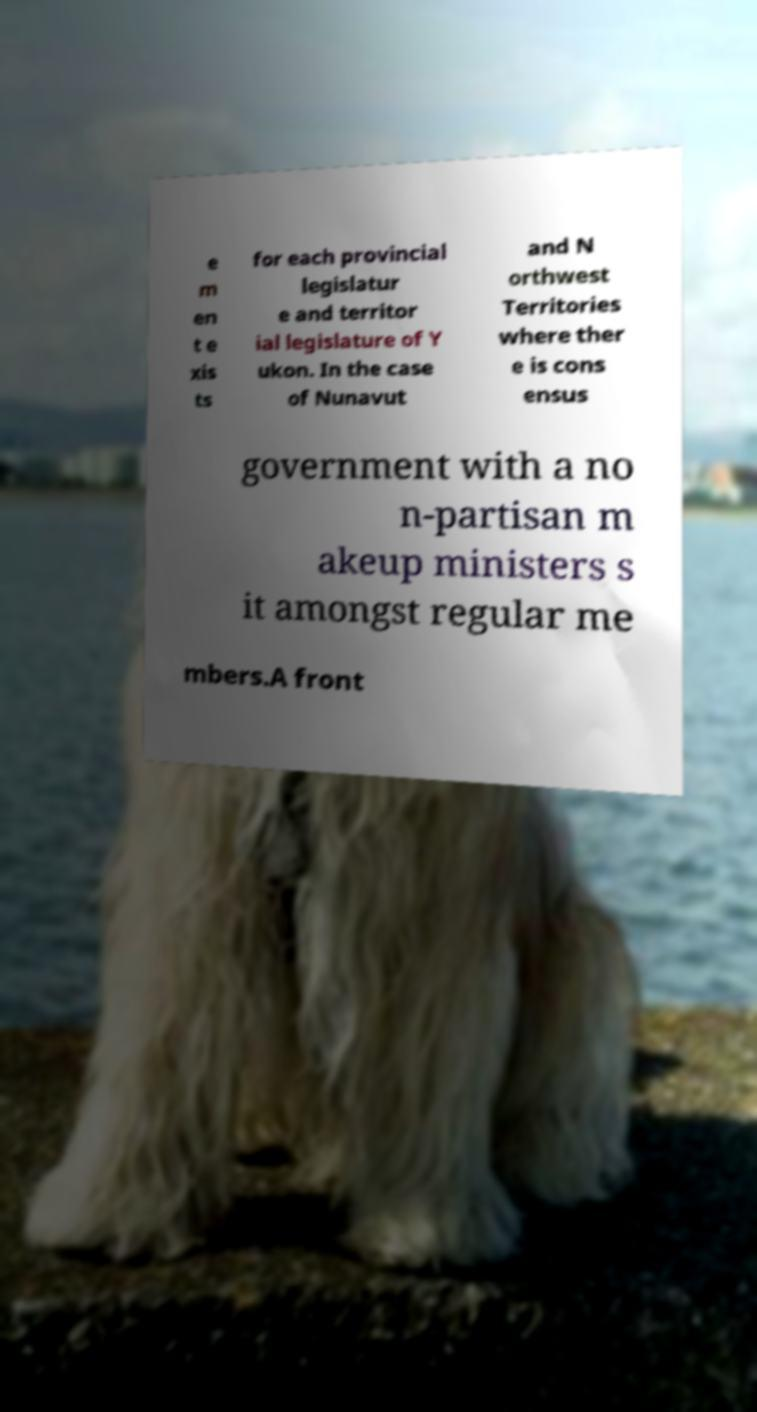There's text embedded in this image that I need extracted. Can you transcribe it verbatim? e m en t e xis ts for each provincial legislatur e and territor ial legislature of Y ukon. In the case of Nunavut and N orthwest Territories where ther e is cons ensus government with a no n-partisan m akeup ministers s it amongst regular me mbers.A front 